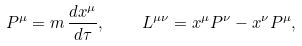Convert formula to latex. <formula><loc_0><loc_0><loc_500><loc_500>P ^ { \mu } = m \, \frac { d x ^ { \mu } } { d \tau } , \quad L ^ { \mu \nu } = x ^ { \mu } P ^ { \nu } - x ^ { \nu } P ^ { \mu } ,</formula> 